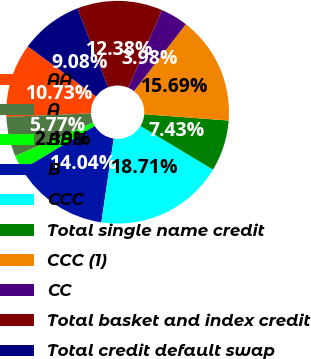Convert chart to OTSL. <chart><loc_0><loc_0><loc_500><loc_500><pie_chart><fcel>AA<fcel>A<fcel>BBB<fcel>B<fcel>CCC<fcel>Total single name credit<fcel>CCC (1)<fcel>CC<fcel>Total basket and index credit<fcel>Total credit default swap<nl><fcel>10.73%<fcel>5.77%<fcel>2.19%<fcel>14.04%<fcel>18.71%<fcel>7.43%<fcel>15.69%<fcel>3.98%<fcel>12.38%<fcel>9.08%<nl></chart> 